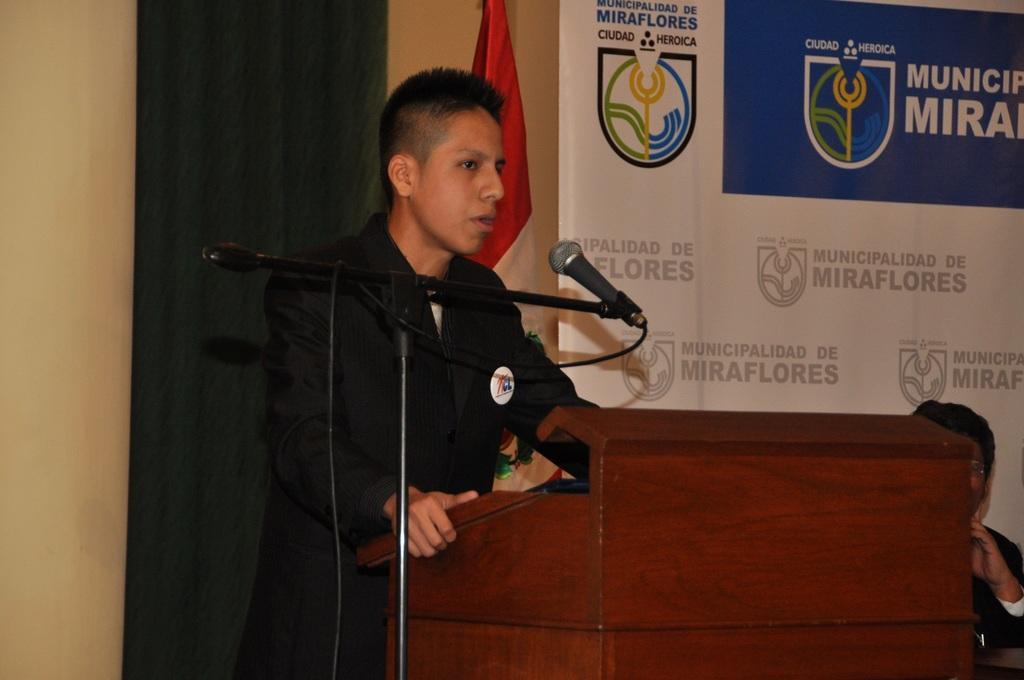Could you give a brief overview of what you see in this image? In the image we can see a man standing, wearing clothes. Here we can see a podium, microphone and cable wire. Behind the man there is a curtain and the flag. Here we can see a poster and there is another man wearing clothes and the person is sitting. 